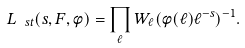Convert formula to latex. <formula><loc_0><loc_0><loc_500><loc_500>L _ { \ s t } ( s , F , \phi ) = \prod _ { \ell } W _ { \ell } ( \phi ( \ell ) \ell ^ { - s } ) ^ { - 1 } .</formula> 